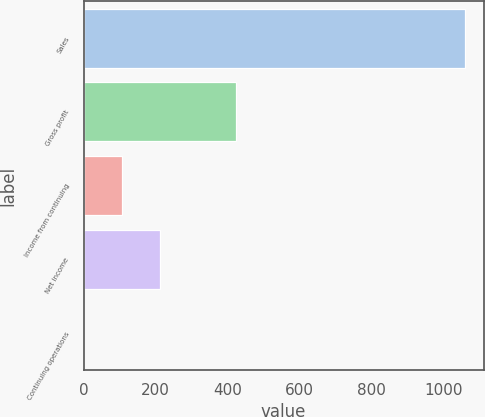Convert chart to OTSL. <chart><loc_0><loc_0><loc_500><loc_500><bar_chart><fcel>Sales<fcel>Gross profit<fcel>Income from continuing<fcel>Net income<fcel>Continuing operations<nl><fcel>1058.1<fcel>423.41<fcel>106.07<fcel>211.85<fcel>0.29<nl></chart> 